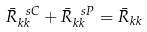<formula> <loc_0><loc_0><loc_500><loc_500>\bar { R } _ { k k } ^ { \ s C } + \bar { R } _ { k k } ^ { \ s P } = \bar { R } _ { k k }</formula> 